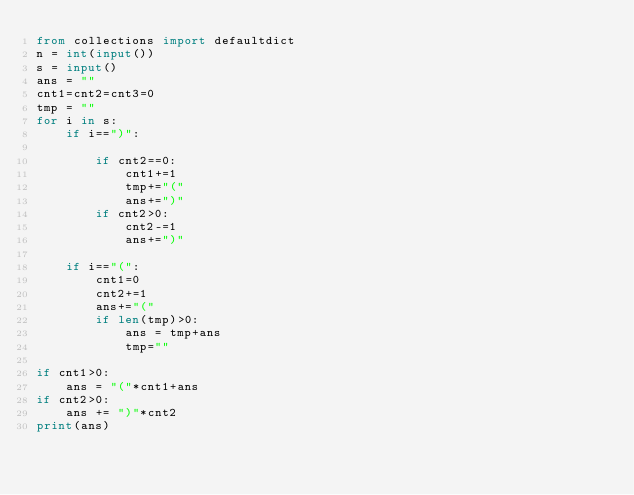<code> <loc_0><loc_0><loc_500><loc_500><_Python_>from collections import defaultdict
n = int(input())
s = input()
ans = ""
cnt1=cnt2=cnt3=0
tmp = ""
for i in s:
    if i==")":

        if cnt2==0:
            cnt1+=1
            tmp+="("
            ans+=")"
        if cnt2>0:
            cnt2-=1
            ans+=")"

    if i=="(":
        cnt1=0
        cnt2+=1
        ans+="("
        if len(tmp)>0:
            ans = tmp+ans
            tmp=""

if cnt1>0:
    ans = "("*cnt1+ans
if cnt2>0:
    ans += ")"*cnt2
print(ans)
</code> 